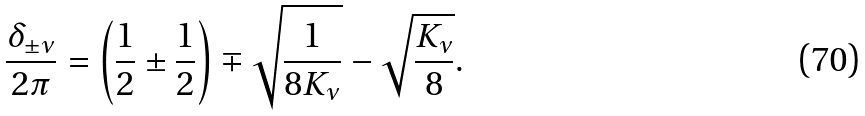Convert formula to latex. <formula><loc_0><loc_0><loc_500><loc_500>\frac { \delta _ { \pm \nu } } { 2 \pi } & = \left ( \frac { 1 } { 2 } \pm \frac { 1 } { 2 } \right ) \mp \sqrt { \frac { 1 } { 8 K _ { \nu } } } - \sqrt { \frac { K _ { \nu } } { 8 } } .</formula> 